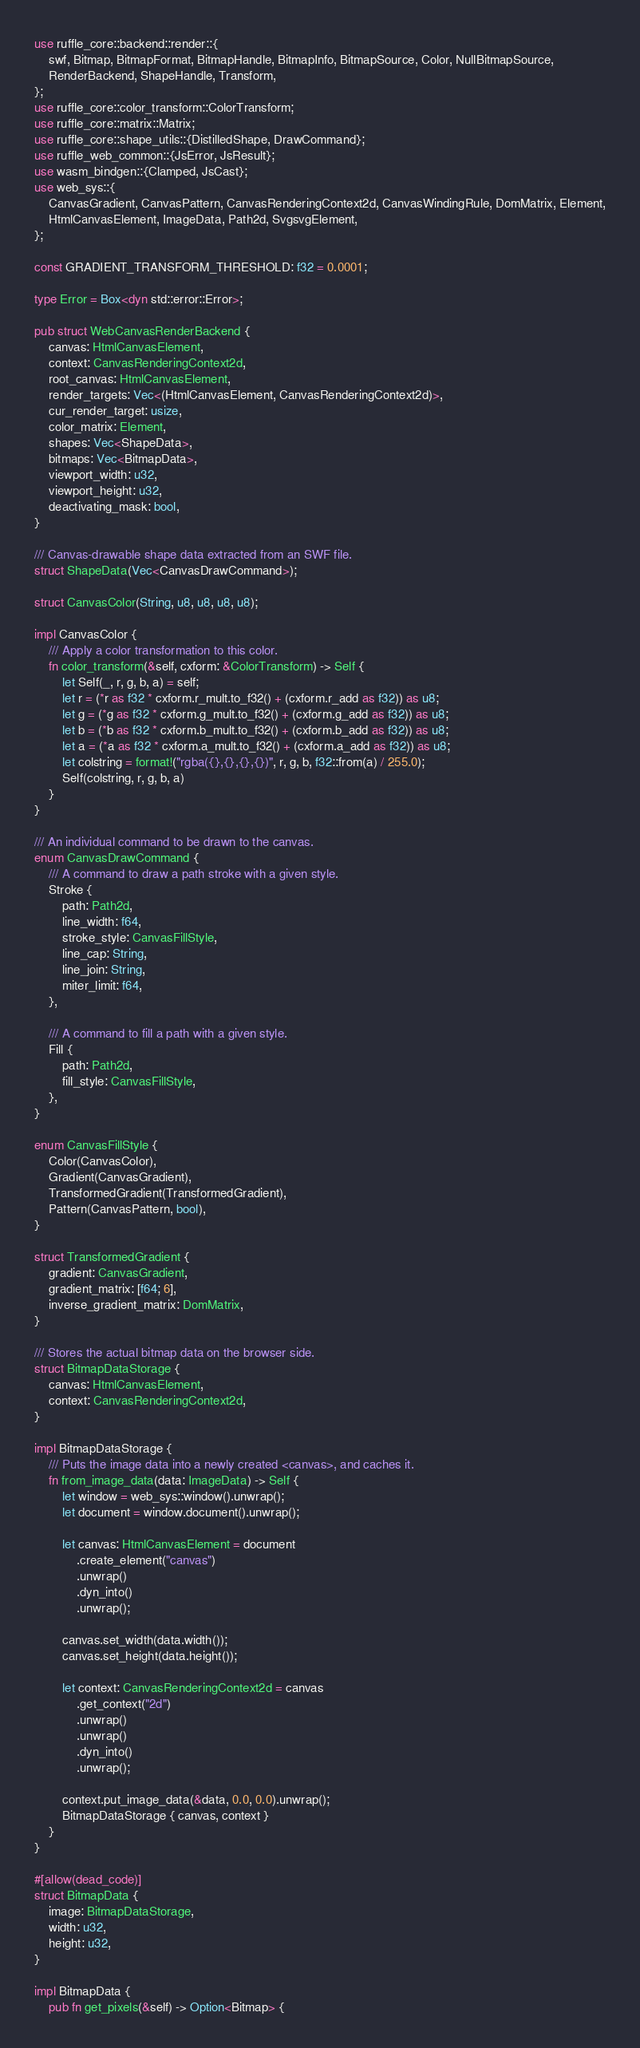Convert code to text. <code><loc_0><loc_0><loc_500><loc_500><_Rust_>use ruffle_core::backend::render::{
    swf, Bitmap, BitmapFormat, BitmapHandle, BitmapInfo, BitmapSource, Color, NullBitmapSource,
    RenderBackend, ShapeHandle, Transform,
};
use ruffle_core::color_transform::ColorTransform;
use ruffle_core::matrix::Matrix;
use ruffle_core::shape_utils::{DistilledShape, DrawCommand};
use ruffle_web_common::{JsError, JsResult};
use wasm_bindgen::{Clamped, JsCast};
use web_sys::{
    CanvasGradient, CanvasPattern, CanvasRenderingContext2d, CanvasWindingRule, DomMatrix, Element,
    HtmlCanvasElement, ImageData, Path2d, SvgsvgElement,
};

const GRADIENT_TRANSFORM_THRESHOLD: f32 = 0.0001;

type Error = Box<dyn std::error::Error>;

pub struct WebCanvasRenderBackend {
    canvas: HtmlCanvasElement,
    context: CanvasRenderingContext2d,
    root_canvas: HtmlCanvasElement,
    render_targets: Vec<(HtmlCanvasElement, CanvasRenderingContext2d)>,
    cur_render_target: usize,
    color_matrix: Element,
    shapes: Vec<ShapeData>,
    bitmaps: Vec<BitmapData>,
    viewport_width: u32,
    viewport_height: u32,
    deactivating_mask: bool,
}

/// Canvas-drawable shape data extracted from an SWF file.
struct ShapeData(Vec<CanvasDrawCommand>);

struct CanvasColor(String, u8, u8, u8, u8);

impl CanvasColor {
    /// Apply a color transformation to this color.
    fn color_transform(&self, cxform: &ColorTransform) -> Self {
        let Self(_, r, g, b, a) = self;
        let r = (*r as f32 * cxform.r_mult.to_f32() + (cxform.r_add as f32)) as u8;
        let g = (*g as f32 * cxform.g_mult.to_f32() + (cxform.g_add as f32)) as u8;
        let b = (*b as f32 * cxform.b_mult.to_f32() + (cxform.b_add as f32)) as u8;
        let a = (*a as f32 * cxform.a_mult.to_f32() + (cxform.a_add as f32)) as u8;
        let colstring = format!("rgba({},{},{},{})", r, g, b, f32::from(a) / 255.0);
        Self(colstring, r, g, b, a)
    }
}

/// An individual command to be drawn to the canvas.
enum CanvasDrawCommand {
    /// A command to draw a path stroke with a given style.
    Stroke {
        path: Path2d,
        line_width: f64,
        stroke_style: CanvasFillStyle,
        line_cap: String,
        line_join: String,
        miter_limit: f64,
    },

    /// A command to fill a path with a given style.
    Fill {
        path: Path2d,
        fill_style: CanvasFillStyle,
    },
}

enum CanvasFillStyle {
    Color(CanvasColor),
    Gradient(CanvasGradient),
    TransformedGradient(TransformedGradient),
    Pattern(CanvasPattern, bool),
}

struct TransformedGradient {
    gradient: CanvasGradient,
    gradient_matrix: [f64; 6],
    inverse_gradient_matrix: DomMatrix,
}

/// Stores the actual bitmap data on the browser side.
struct BitmapDataStorage {
    canvas: HtmlCanvasElement,
    context: CanvasRenderingContext2d,
}

impl BitmapDataStorage {
    /// Puts the image data into a newly created <canvas>, and caches it.
    fn from_image_data(data: ImageData) -> Self {
        let window = web_sys::window().unwrap();
        let document = window.document().unwrap();

        let canvas: HtmlCanvasElement = document
            .create_element("canvas")
            .unwrap()
            .dyn_into()
            .unwrap();

        canvas.set_width(data.width());
        canvas.set_height(data.height());

        let context: CanvasRenderingContext2d = canvas
            .get_context("2d")
            .unwrap()
            .unwrap()
            .dyn_into()
            .unwrap();

        context.put_image_data(&data, 0.0, 0.0).unwrap();
        BitmapDataStorage { canvas, context }
    }
}

#[allow(dead_code)]
struct BitmapData {
    image: BitmapDataStorage,
    width: u32,
    height: u32,
}

impl BitmapData {
    pub fn get_pixels(&self) -> Option<Bitmap> {</code> 